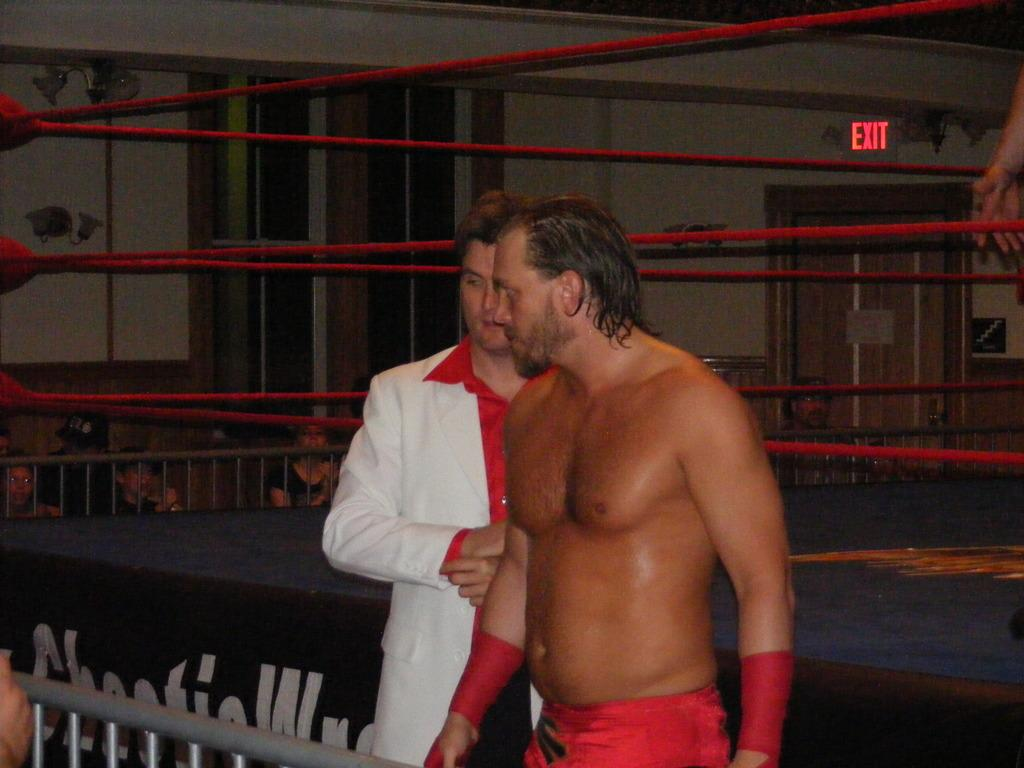What can be seen in the image involving men? There are men standing in the image. What structure is present in the image? There is a door in the image. What is the main feature of the image? There is a boxing ring in the image. What type of burn can be seen on the judge's hand in the image? There is no judge or burn present in the image; it only features men standing near a boxing ring. 